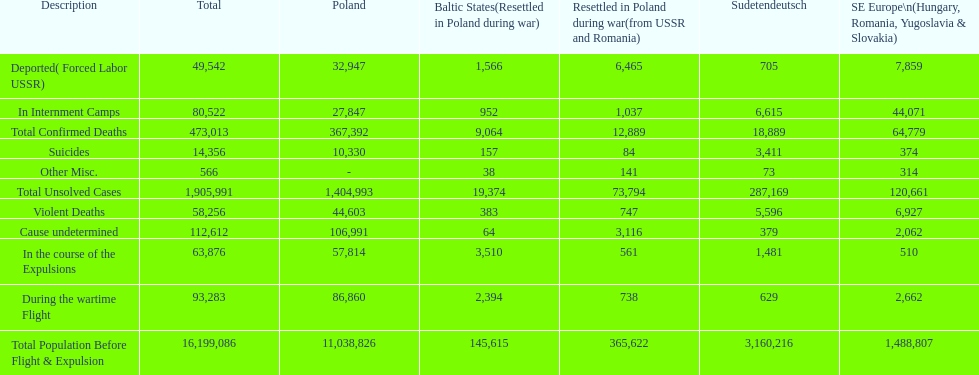Did any location have no violent deaths? No. 